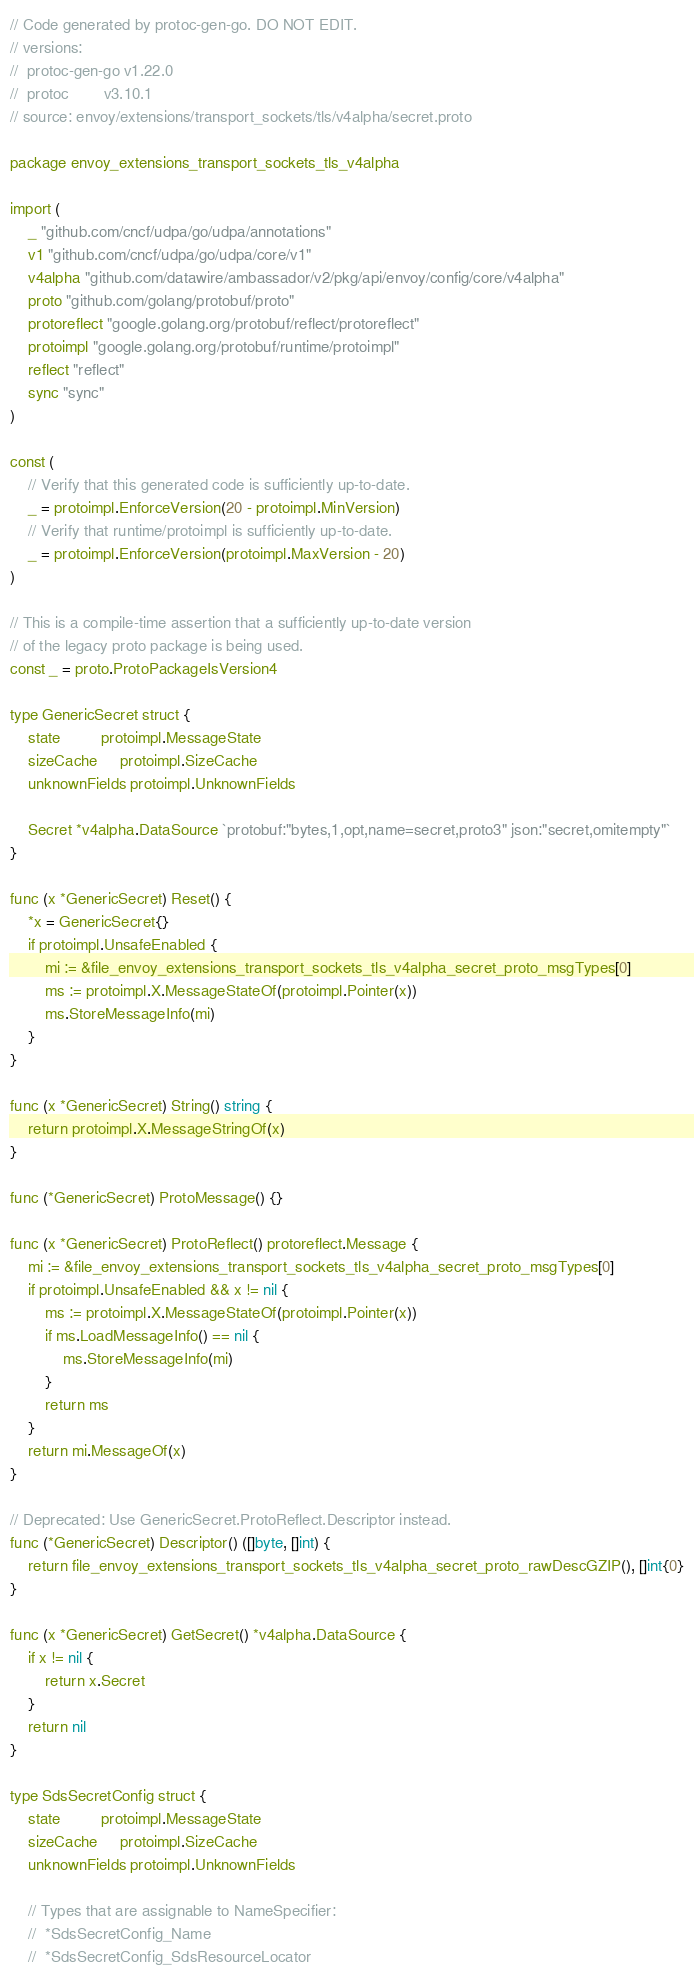<code> <loc_0><loc_0><loc_500><loc_500><_Go_>// Code generated by protoc-gen-go. DO NOT EDIT.
// versions:
// 	protoc-gen-go v1.22.0
// 	protoc        v3.10.1
// source: envoy/extensions/transport_sockets/tls/v4alpha/secret.proto

package envoy_extensions_transport_sockets_tls_v4alpha

import (
	_ "github.com/cncf/udpa/go/udpa/annotations"
	v1 "github.com/cncf/udpa/go/udpa/core/v1"
	v4alpha "github.com/datawire/ambassador/v2/pkg/api/envoy/config/core/v4alpha"
	proto "github.com/golang/protobuf/proto"
	protoreflect "google.golang.org/protobuf/reflect/protoreflect"
	protoimpl "google.golang.org/protobuf/runtime/protoimpl"
	reflect "reflect"
	sync "sync"
)

const (
	// Verify that this generated code is sufficiently up-to-date.
	_ = protoimpl.EnforceVersion(20 - protoimpl.MinVersion)
	// Verify that runtime/protoimpl is sufficiently up-to-date.
	_ = protoimpl.EnforceVersion(protoimpl.MaxVersion - 20)
)

// This is a compile-time assertion that a sufficiently up-to-date version
// of the legacy proto package is being used.
const _ = proto.ProtoPackageIsVersion4

type GenericSecret struct {
	state         protoimpl.MessageState
	sizeCache     protoimpl.SizeCache
	unknownFields protoimpl.UnknownFields

	Secret *v4alpha.DataSource `protobuf:"bytes,1,opt,name=secret,proto3" json:"secret,omitempty"`
}

func (x *GenericSecret) Reset() {
	*x = GenericSecret{}
	if protoimpl.UnsafeEnabled {
		mi := &file_envoy_extensions_transport_sockets_tls_v4alpha_secret_proto_msgTypes[0]
		ms := protoimpl.X.MessageStateOf(protoimpl.Pointer(x))
		ms.StoreMessageInfo(mi)
	}
}

func (x *GenericSecret) String() string {
	return protoimpl.X.MessageStringOf(x)
}

func (*GenericSecret) ProtoMessage() {}

func (x *GenericSecret) ProtoReflect() protoreflect.Message {
	mi := &file_envoy_extensions_transport_sockets_tls_v4alpha_secret_proto_msgTypes[0]
	if protoimpl.UnsafeEnabled && x != nil {
		ms := protoimpl.X.MessageStateOf(protoimpl.Pointer(x))
		if ms.LoadMessageInfo() == nil {
			ms.StoreMessageInfo(mi)
		}
		return ms
	}
	return mi.MessageOf(x)
}

// Deprecated: Use GenericSecret.ProtoReflect.Descriptor instead.
func (*GenericSecret) Descriptor() ([]byte, []int) {
	return file_envoy_extensions_transport_sockets_tls_v4alpha_secret_proto_rawDescGZIP(), []int{0}
}

func (x *GenericSecret) GetSecret() *v4alpha.DataSource {
	if x != nil {
		return x.Secret
	}
	return nil
}

type SdsSecretConfig struct {
	state         protoimpl.MessageState
	sizeCache     protoimpl.SizeCache
	unknownFields protoimpl.UnknownFields

	// Types that are assignable to NameSpecifier:
	//	*SdsSecretConfig_Name
	//	*SdsSecretConfig_SdsResourceLocator</code> 